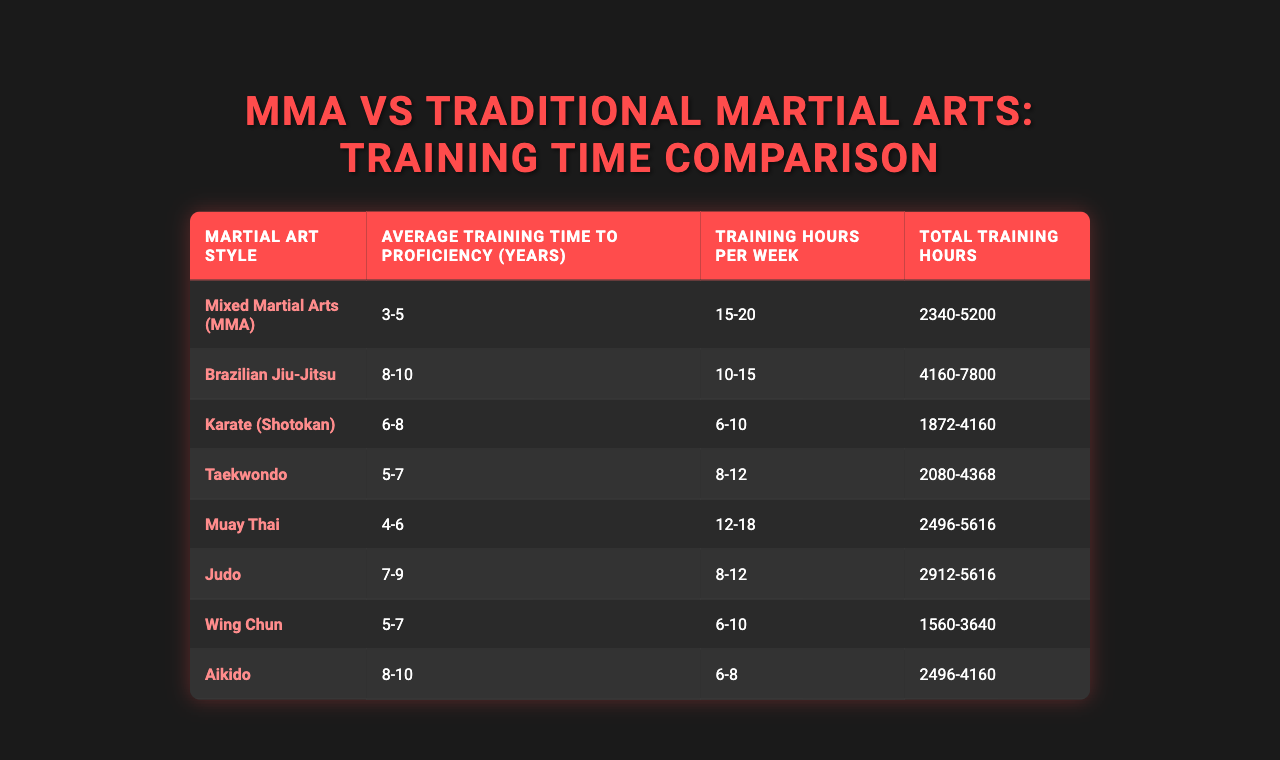What is the average training time to proficiency for MMA? The table lists the average training time for MMA as "3-5 years". The specific average is not given as a single number, but this range indicates that it takes at least 3 years and up to 5 years to achieve proficiency.
Answer: 3-5 years Which martial art requires the longest average training time to proficiency? Looking at the table, Brazilian Jiu-Jitsu has the longest average training time, listed as "8-10 years". This is greater than the other styles mentioned in the table.
Answer: Brazilian Jiu-Jitsu What is the average training time for Karate and Taekwondo combined? The average training time for Karate is "6-8 years" and for Taekwondo is "5-7 years". Calculating the averages: Karate average is 7 years and Taekwondo average is 6 years. The combined average is (7 + 6)/2 = 6.5 years.
Answer: 6.5 years Is the average training time for Mixed Martial Arts shorter than that for Muay Thai? The average training time for MMA is "3-5 years", while Muay Thai is "4-6 years". Since 5 years (max of MMA) is less than 6 years (max of Muay Thai), the average for MMA is indeed shorter.
Answer: Yes What is the total range of training hours for both Karate and Aikido? The total training hours for Karate range from "1872 to 4160 hours", and for Aikido it is "2496 to 4160 hours". The combined range for both would be from the minimum of both (1872) to the maximum of both (4160). This gives a total range of 1872 to 4160 hours.
Answer: 1872 to 4160 hours Which martial art styles have an average training time of 6 years or more? From the table, Karate, Taekwondo, Judo, Brazilian Jiu-Jitsu, and Aikido all have average training times of 6 years or greater based on their proficiency ranges.
Answer: Karate, Taekwondo, Judo, Brazilian Jiu-Jitsu, Aikido How many training hours per week does Wing Chun require on average? The table states that Wing Chun's training hours per week range from "6 to 10 hours". To find the average, they are added (6 + 10) and divided by 2, which equals to 8 hours.
Answer: 8 hours What is the median of the average training times of all martial arts styles listed? To find the median, we first list the average training times numerically: 3.5 (MMA), 8.5 (BJJ), 7 (Karate), 6 (Taekwondo), 5 (Muay Thai), 8 (Judo), 6 (Wing Chun), 9 (Aikido). The median (middle value) of this dataset, when arranged, is 7 years as it is the fourth value of the ordered set.
Answer: 7 years Is the average training time for Taekwondo greater than that for Muay Thai? Taekwondo has an average training time of "5-7 years" while Muay Thai has "4-6 years". The maximum of Taekwondo is greater than the maximum of Muay Thai, therefore Taekwondo's average training time is greater.
Answer: Yes Which martial art has the smallest total training hours range? By looking at the total training hours, Wing Chun has the smallest range going from "1560 to 3640 hours", which is a difference of 2080 hours, the smallest of the listed ranges.
Answer: Wing Chun What is the average weekly training hours for Brazilian Jiu-Jitsu? The average training hours per week for Brazilian Jiu-Jitsu is given in the table as "10-15 hours". To find the average: (10 + 15)/2 = 12.5 hours.
Answer: 12.5 hours 